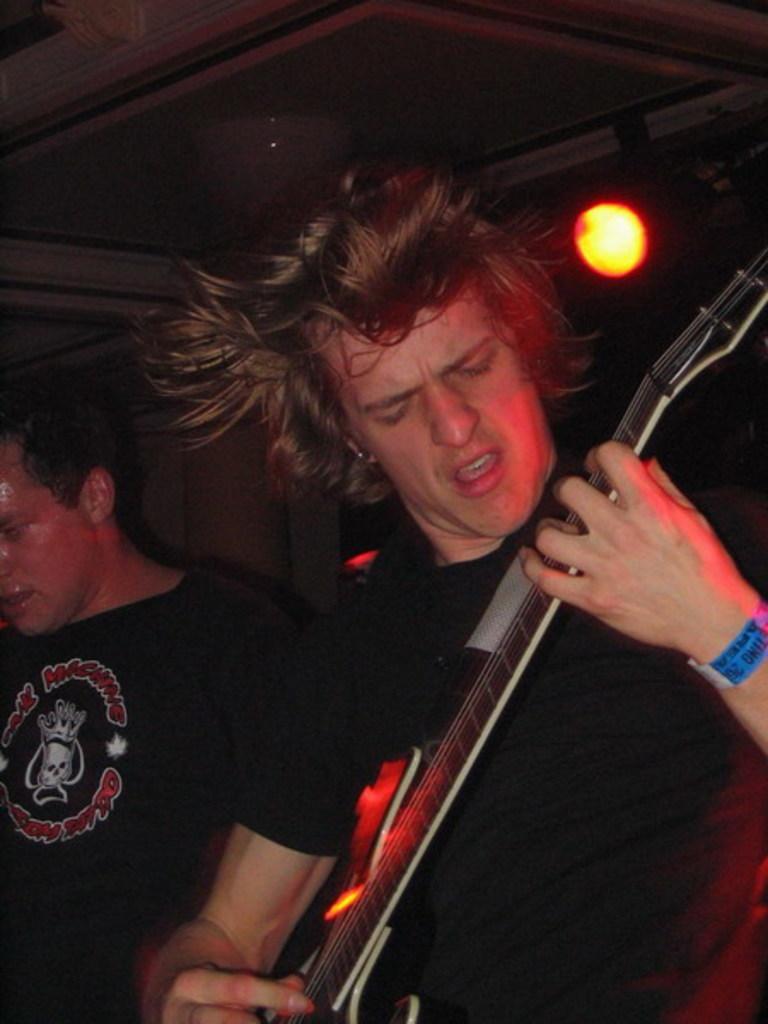Could you give a brief overview of what you see in this image? There is a man in black costume playing guitar and other man standing beside him. At there back there is a yellow color flashlight focusing on them. 